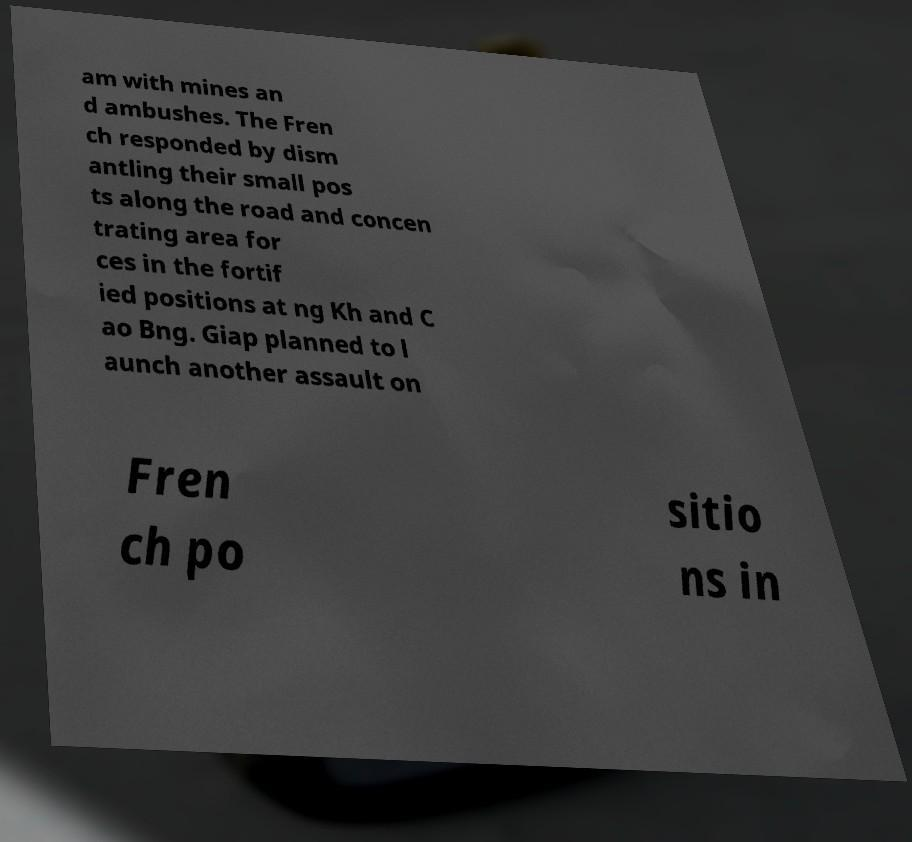I need the written content from this picture converted into text. Can you do that? am with mines an d ambushes. The Fren ch responded by dism antling their small pos ts along the road and concen trating area for ces in the fortif ied positions at ng Kh and C ao Bng. Giap planned to l aunch another assault on Fren ch po sitio ns in 